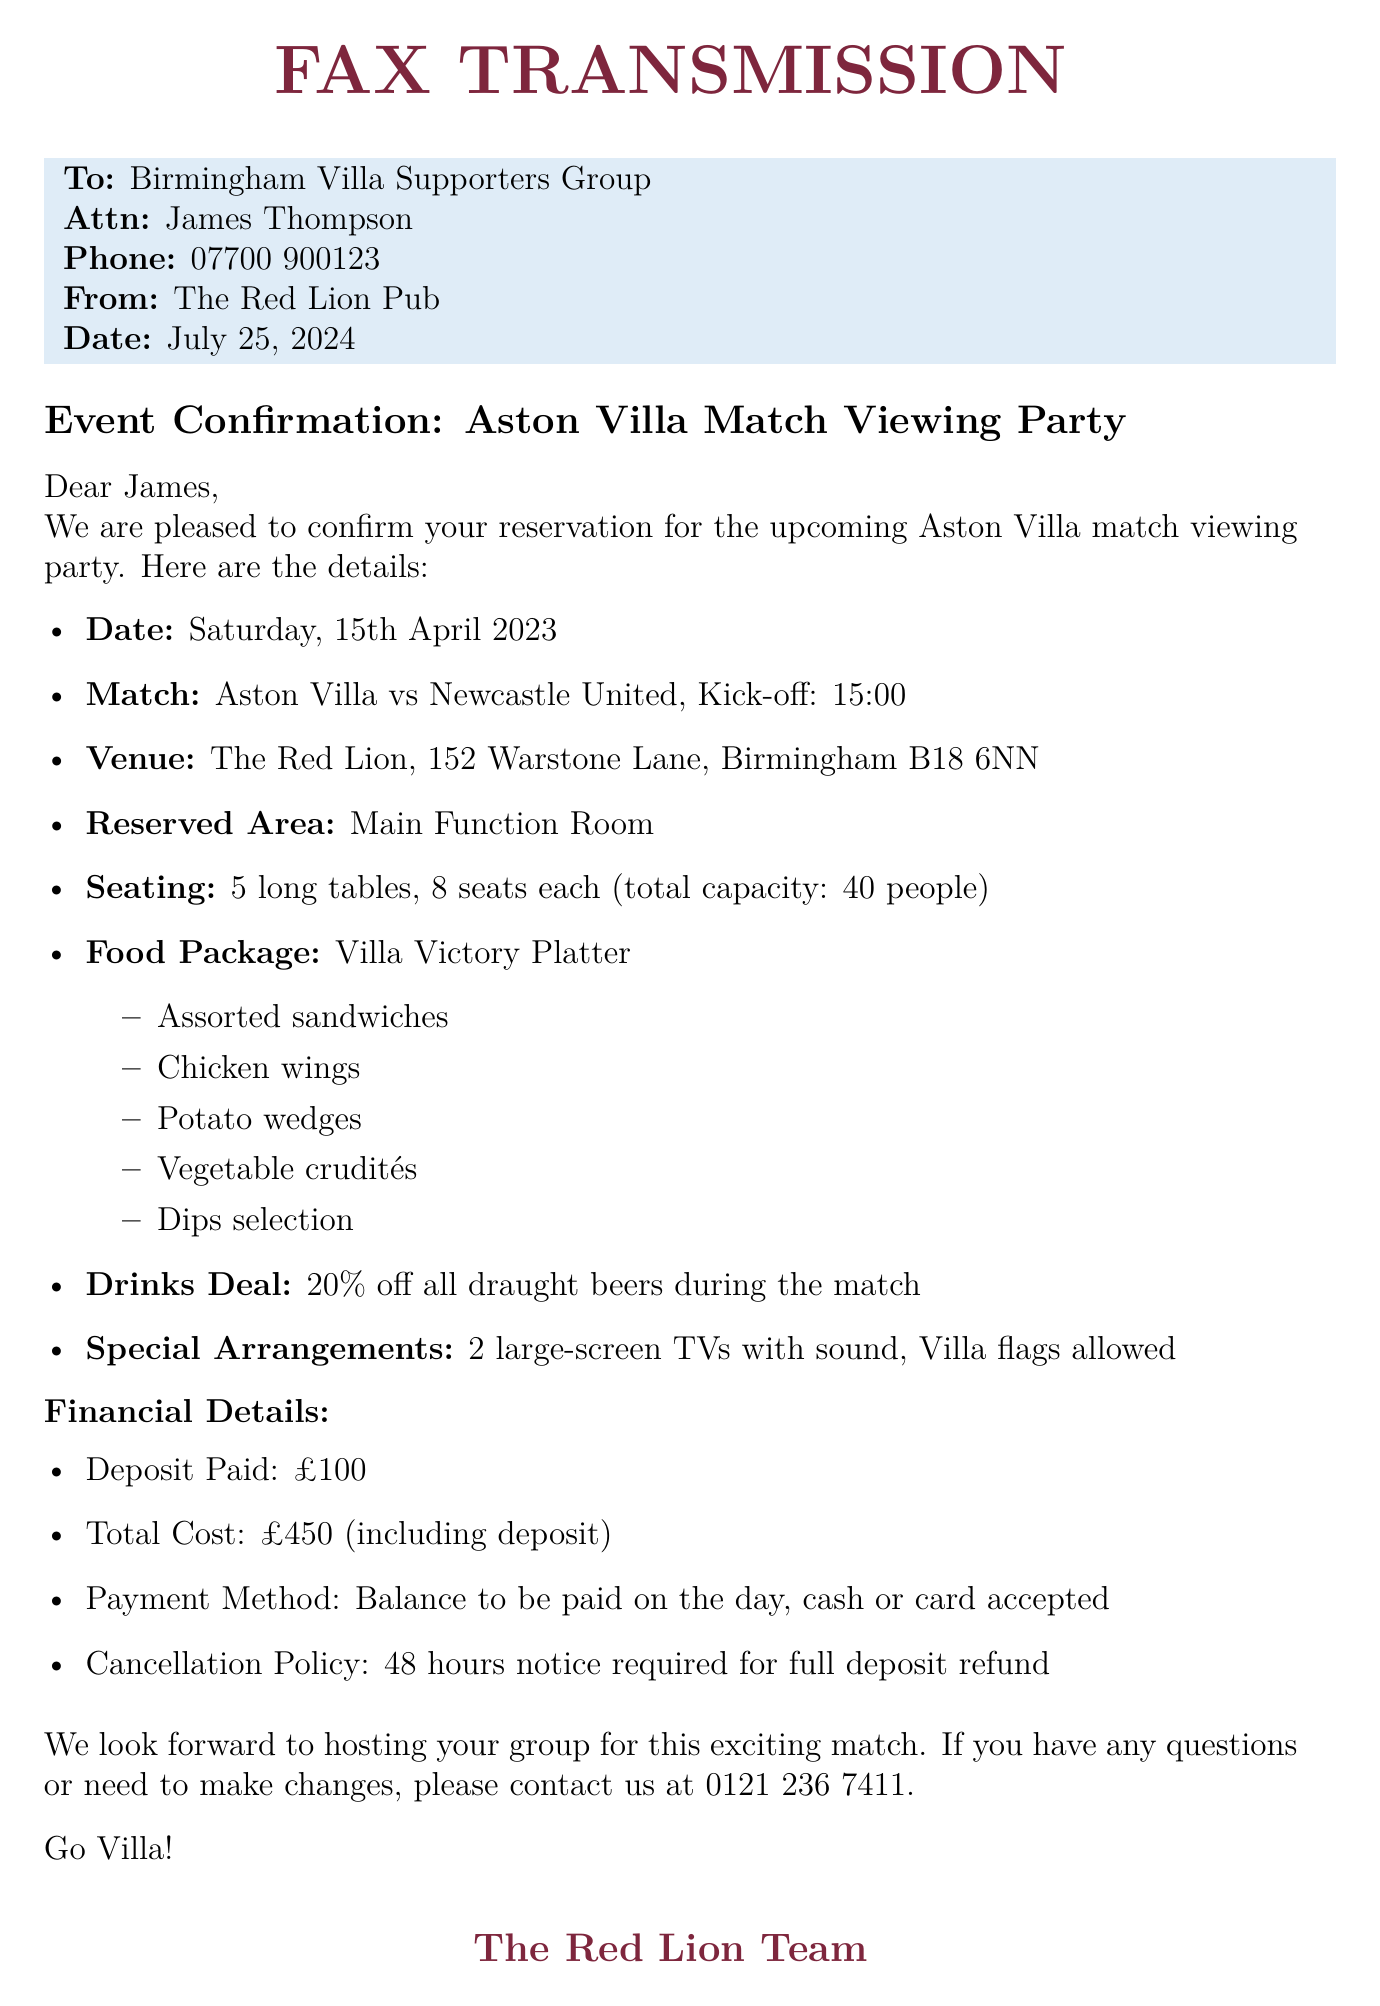what is the date of the match? The date of the match is specified in the document as Saturday, 15th April 2023.
Answer: Saturday, 15th April 2023 who is the match against? The document states that the match is between Aston Villa and Newcastle United.
Answer: Newcastle United how many seats are there at the reserved area? The reserved area details indicate that there are 40 seats available in total.
Answer: 40 seats what type of food package is mentioned? The document features the "Villa Victory Platter" as the food package for the event.
Answer: Villa Victory Platter what is the deposit amount paid? According to the financial details, the deposit paid is £100.
Answer: £100 what is the drinks deal during the match? The document states a 20% discount on all draught beers during the match.
Answer: 20% off all draught beers how many large-screen TVs are available? The special arrangements mention that there are 2 large-screen TVs available.
Answer: 2 large-screen TVs what is the total cost of the reservation? The document specifies that the total cost including the deposit is £450.
Answer: £450 what is the cancellation policy? The cancellation policy in the document requires 48 hours notice for a full deposit refund.
Answer: 48 hours notice required 